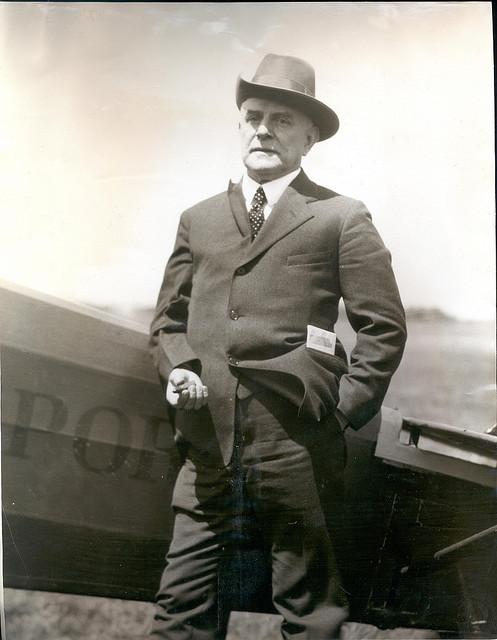How can you tell this picture is vintage?
Give a very brief answer. Black and white. Is he wearing sunglasses?
Write a very short answer. No. How many hats are there?
Keep it brief. 1. What is the man wearing?
Short answer required. Suit. Is this man probably physically fit?
Write a very short answer. Yes. Is this man wearing a cap?
Write a very short answer. Yes. What is on the man's head?
Answer briefly. Hat. Is this person wearing a belt?
Write a very short answer. No. What is in the man's pocket?
Concise answer only. Paper. What type of hat is the man wearing?
Keep it brief. Cowboy hat. Is this a current photo?
Concise answer only. No. What is in the man's left hand?
Concise answer only. Coins. 